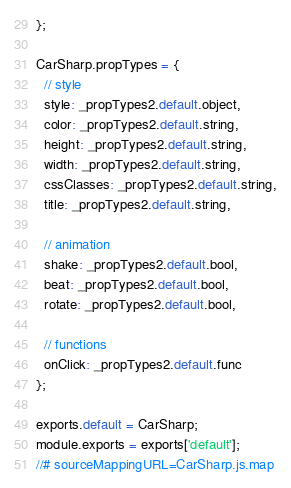Convert code to text. <code><loc_0><loc_0><loc_500><loc_500><_JavaScript_>};

CarSharp.propTypes = {
  // style
  style: _propTypes2.default.object,
  color: _propTypes2.default.string,
  height: _propTypes2.default.string,
  width: _propTypes2.default.string,
  cssClasses: _propTypes2.default.string,
  title: _propTypes2.default.string,

  // animation
  shake: _propTypes2.default.bool,
  beat: _propTypes2.default.bool,
  rotate: _propTypes2.default.bool,

  // functions
  onClick: _propTypes2.default.func
};

exports.default = CarSharp;
module.exports = exports['default'];
//# sourceMappingURL=CarSharp.js.map</code> 